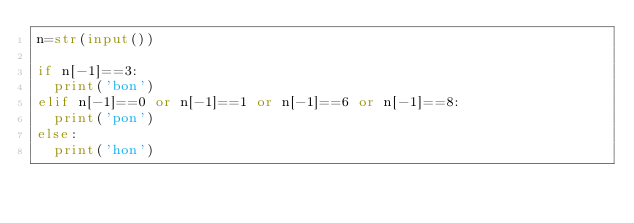Convert code to text. <code><loc_0><loc_0><loc_500><loc_500><_Python_>n=str(input())

if n[-1]==3:
  print('bon')
elif n[-1]==0 or n[-1]==1 or n[-1]==6 or n[-1]==8:
  print('pon')
else:
  print('hon')</code> 